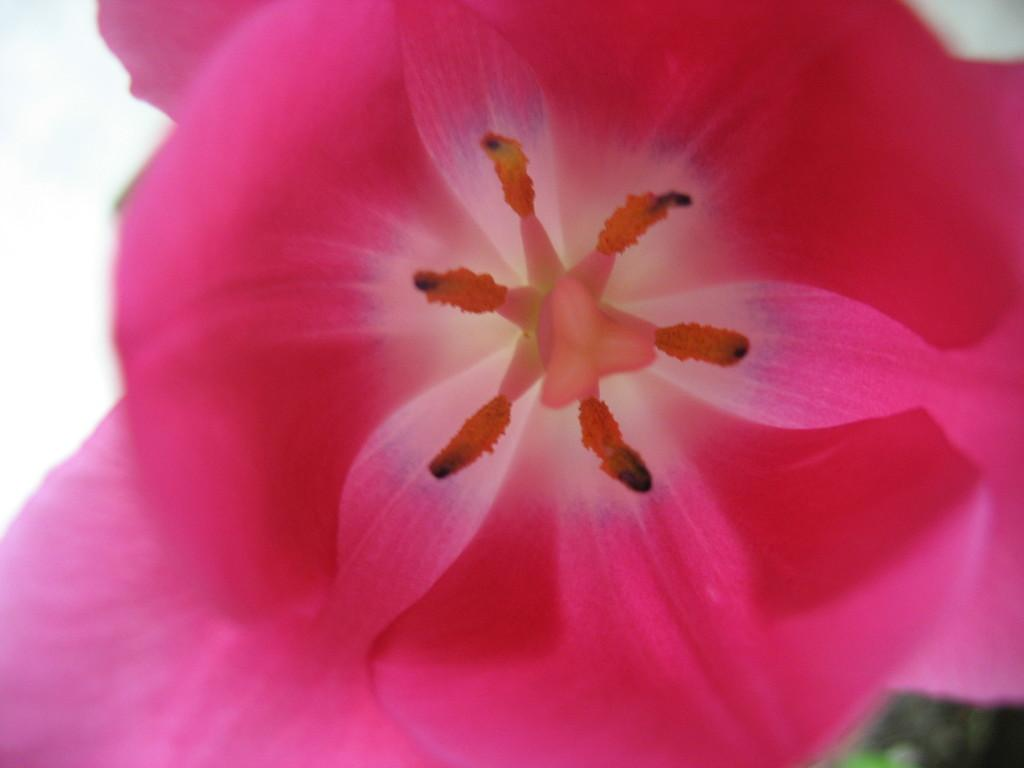What type of flower is in the image? There is a pink flower in the image. What color is the background of the image? The background of the image is white. What type of potato is hidden behind the flower in the image? There is no potato present in the image; it only features a pink flower against a white background. 